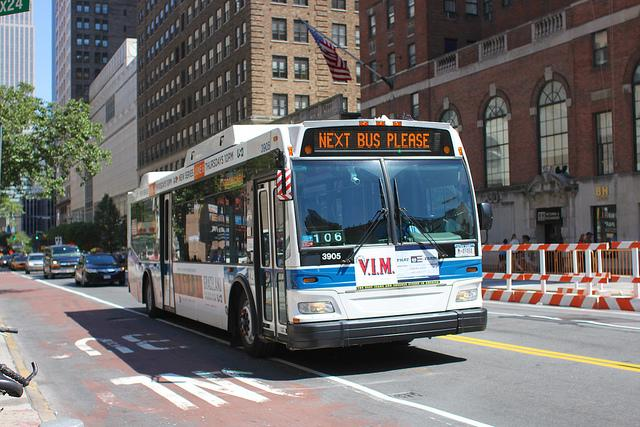Where does the bus go next?

Choices:
A) bus stop
B) bus terminal
C) downtown
D) uptown bus terminal 